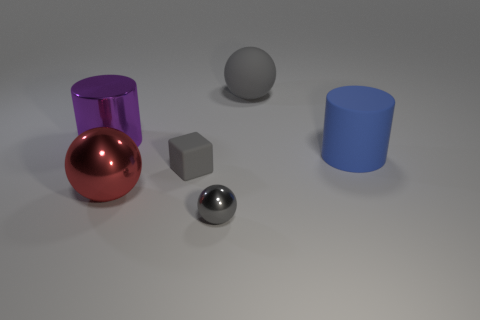There is a tiny matte thing that is the same color as the matte sphere; what is its shape?
Offer a very short reply. Cube. There is a metal object that is the same color as the matte ball; what size is it?
Ensure brevity in your answer.  Small. What number of small cubes are the same color as the rubber sphere?
Ensure brevity in your answer.  1. There is a blue object that is the same material as the cube; what size is it?
Make the answer very short. Large. How many purple shiny objects have the same shape as the tiny matte object?
Make the answer very short. 0. Are there more small matte cubes right of the gray matte cube than big red metal objects right of the big red metal sphere?
Your response must be concise. No. There is a small shiny sphere; does it have the same color as the matte thing to the left of the large gray matte thing?
Provide a succinct answer. Yes. There is a sphere that is the same size as the red thing; what material is it?
Ensure brevity in your answer.  Rubber. How many objects are either large cylinders or metal balls that are in front of the red shiny thing?
Offer a very short reply. 3. There is a blue cylinder; does it have the same size as the gray ball in front of the big blue rubber thing?
Offer a very short reply. No. 